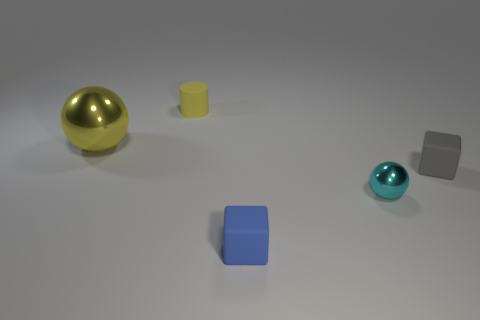Does the tiny block that is on the left side of the small gray thing have the same material as the ball that is on the left side of the tiny sphere?
Provide a succinct answer. No. There is a tiny cube that is in front of the rubber cube on the right side of the tiny cube in front of the small gray rubber thing; what color is it?
Your response must be concise. Blue. How many other objects are the same shape as the tiny yellow object?
Provide a short and direct response. 0. Is the tiny cylinder the same color as the large metallic ball?
Your response must be concise. Yes. How many things are yellow matte cylinders or cubes right of the blue thing?
Keep it short and to the point. 2. Are there any yellow things of the same size as the blue rubber block?
Offer a very short reply. Yes. Are the tiny blue cube and the large sphere made of the same material?
Give a very brief answer. No. How many things are either large objects or tiny metallic objects?
Offer a very short reply. 2. How big is the gray rubber thing?
Ensure brevity in your answer.  Small. Is the number of small yellow cylinders less than the number of tiny shiny cylinders?
Give a very brief answer. No. 